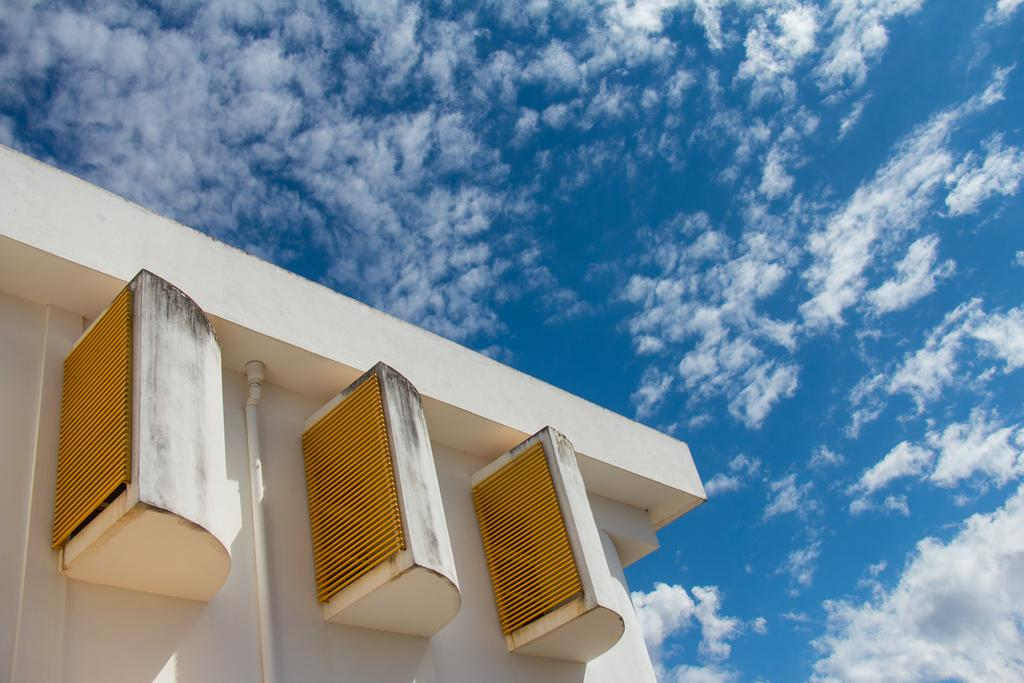What structure is located on the left side of the image? There is a building on the left side of the image. What feature can be seen on the building? There appear to be ventilators on the building. What is visible in most of the image? The sky is visible in most of the image. Can you tell me how many geese are depicted in the image? There are no geese present in the image. What type of book is being read by the building in the image? There is no book or reading activity depicted in the image; it features a building with ventilators and a visible sky. 